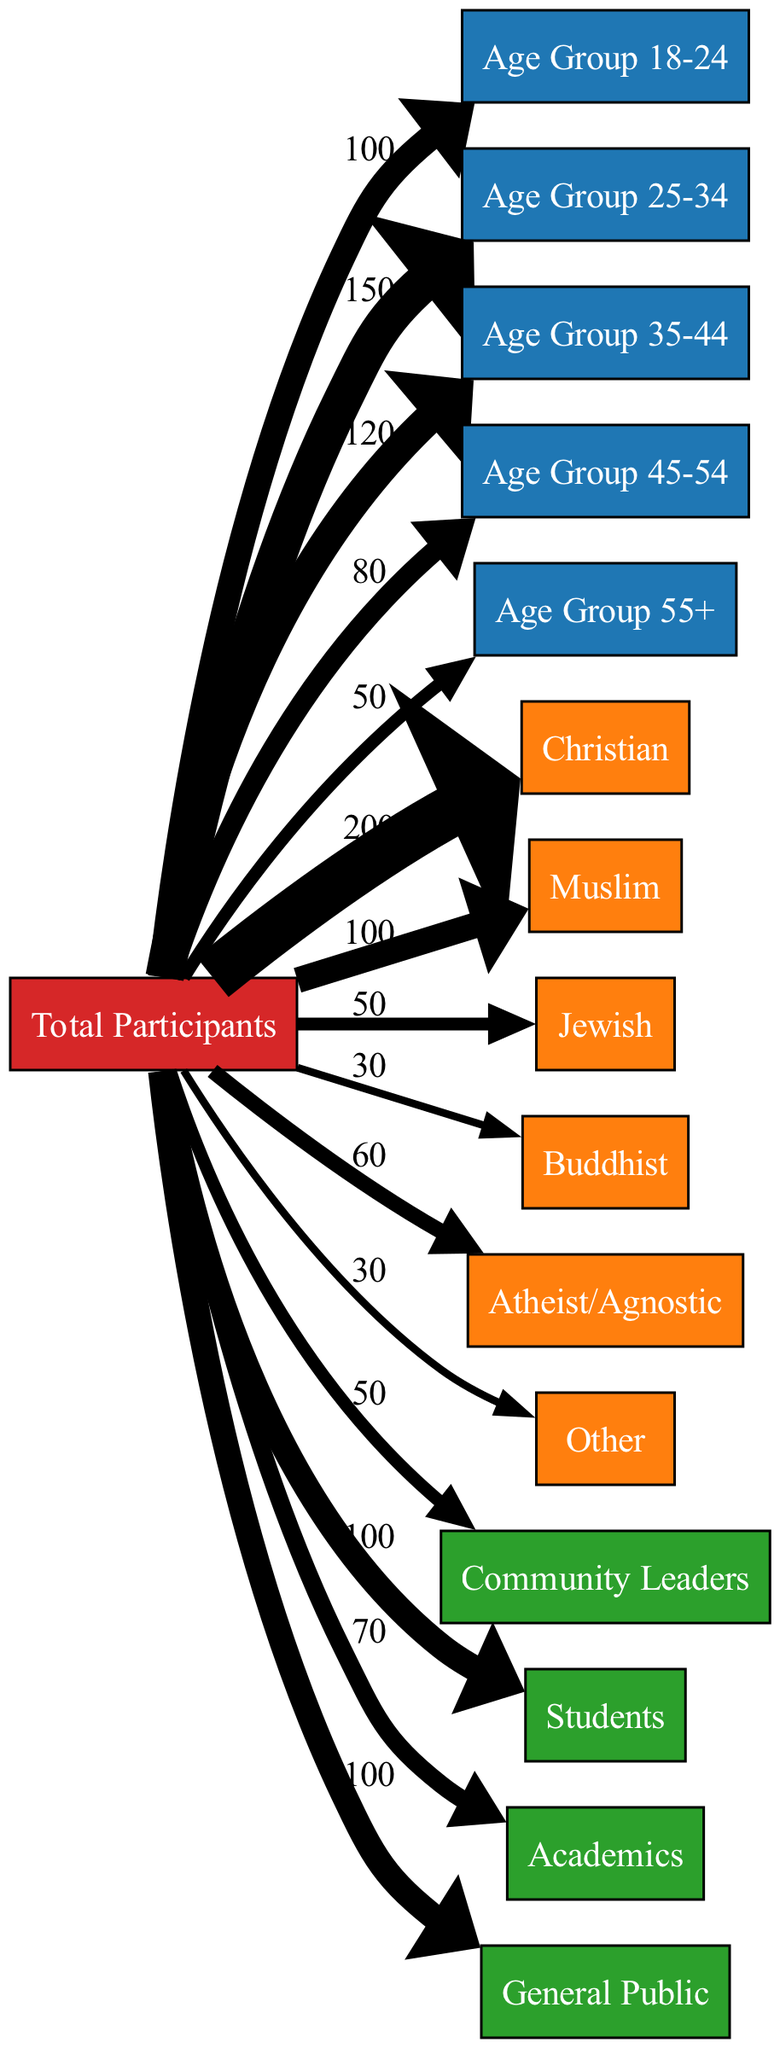What is the total number of participants? The diagram indicates that the total number of participants flows towards various demographics. To find the total, I can add the values for each demographic category provided (100 + 150 + 120 + 80 + 50 + 200 + 100 + 50 + 30 + 60 + 30 + 50 + 100 + 70 + 100) which sums to 1,300 total participants.
Answer: 1300 Which age group has the highest number of participants? By examining the flow from "Total Participants" to each age group, the highest value is at "Age Group 25-34" with a flow of 150 participants, more than any other age group.
Answer: Age Group 25-34 How many participants identified as Atheist/Agnostic? The flow from "Total Participants" to "Atheist/Agnostic" shows a direct value of 60 participants. This value is directly indicated in the diagram.
Answer: 60 How many participants are from the "General Public"? The data shows a flow of 100 participants from "Total Participants" to "General Public." This can be read directly from the link between these two nodes.
Answer: 100 What percentage of participants are Christians? The flow of participants from "Total Participants" to "Christian" is 200. To find the percentage, I take (200/1300) * 100, which calculates to approximately 15.38%.
Answer: 15.38% How many more participants are in the 18-24 age group compared to the 45-54 age group? The 18-24 age group has 100 participants, while the 45-54 age group has 80 participants. The difference can be calculated by subtracting 80 from 100, resulting in 20 more participants in the younger group.
Answer: 20 Which demographic has the least representation in terms of participants? Observing the flows towards each demographic category, "Buddhist" has the least value at 30 participants, making it the demographic with the least representation visually and numerically.
Answer: Buddhist How many participants come from the academic background? From "Total Participants," the flow to "Academics" shows 70 participants. This is a direct observation from the diagram itself.
Answer: 70 Which two demographics combined have the highest participants? By inspecting the values, "Christian" has 200 and "Age Group 25-34" has 150, combining these gives 350 which is the highest when compared to any other combinations of two demographics examined.
Answer: 350 